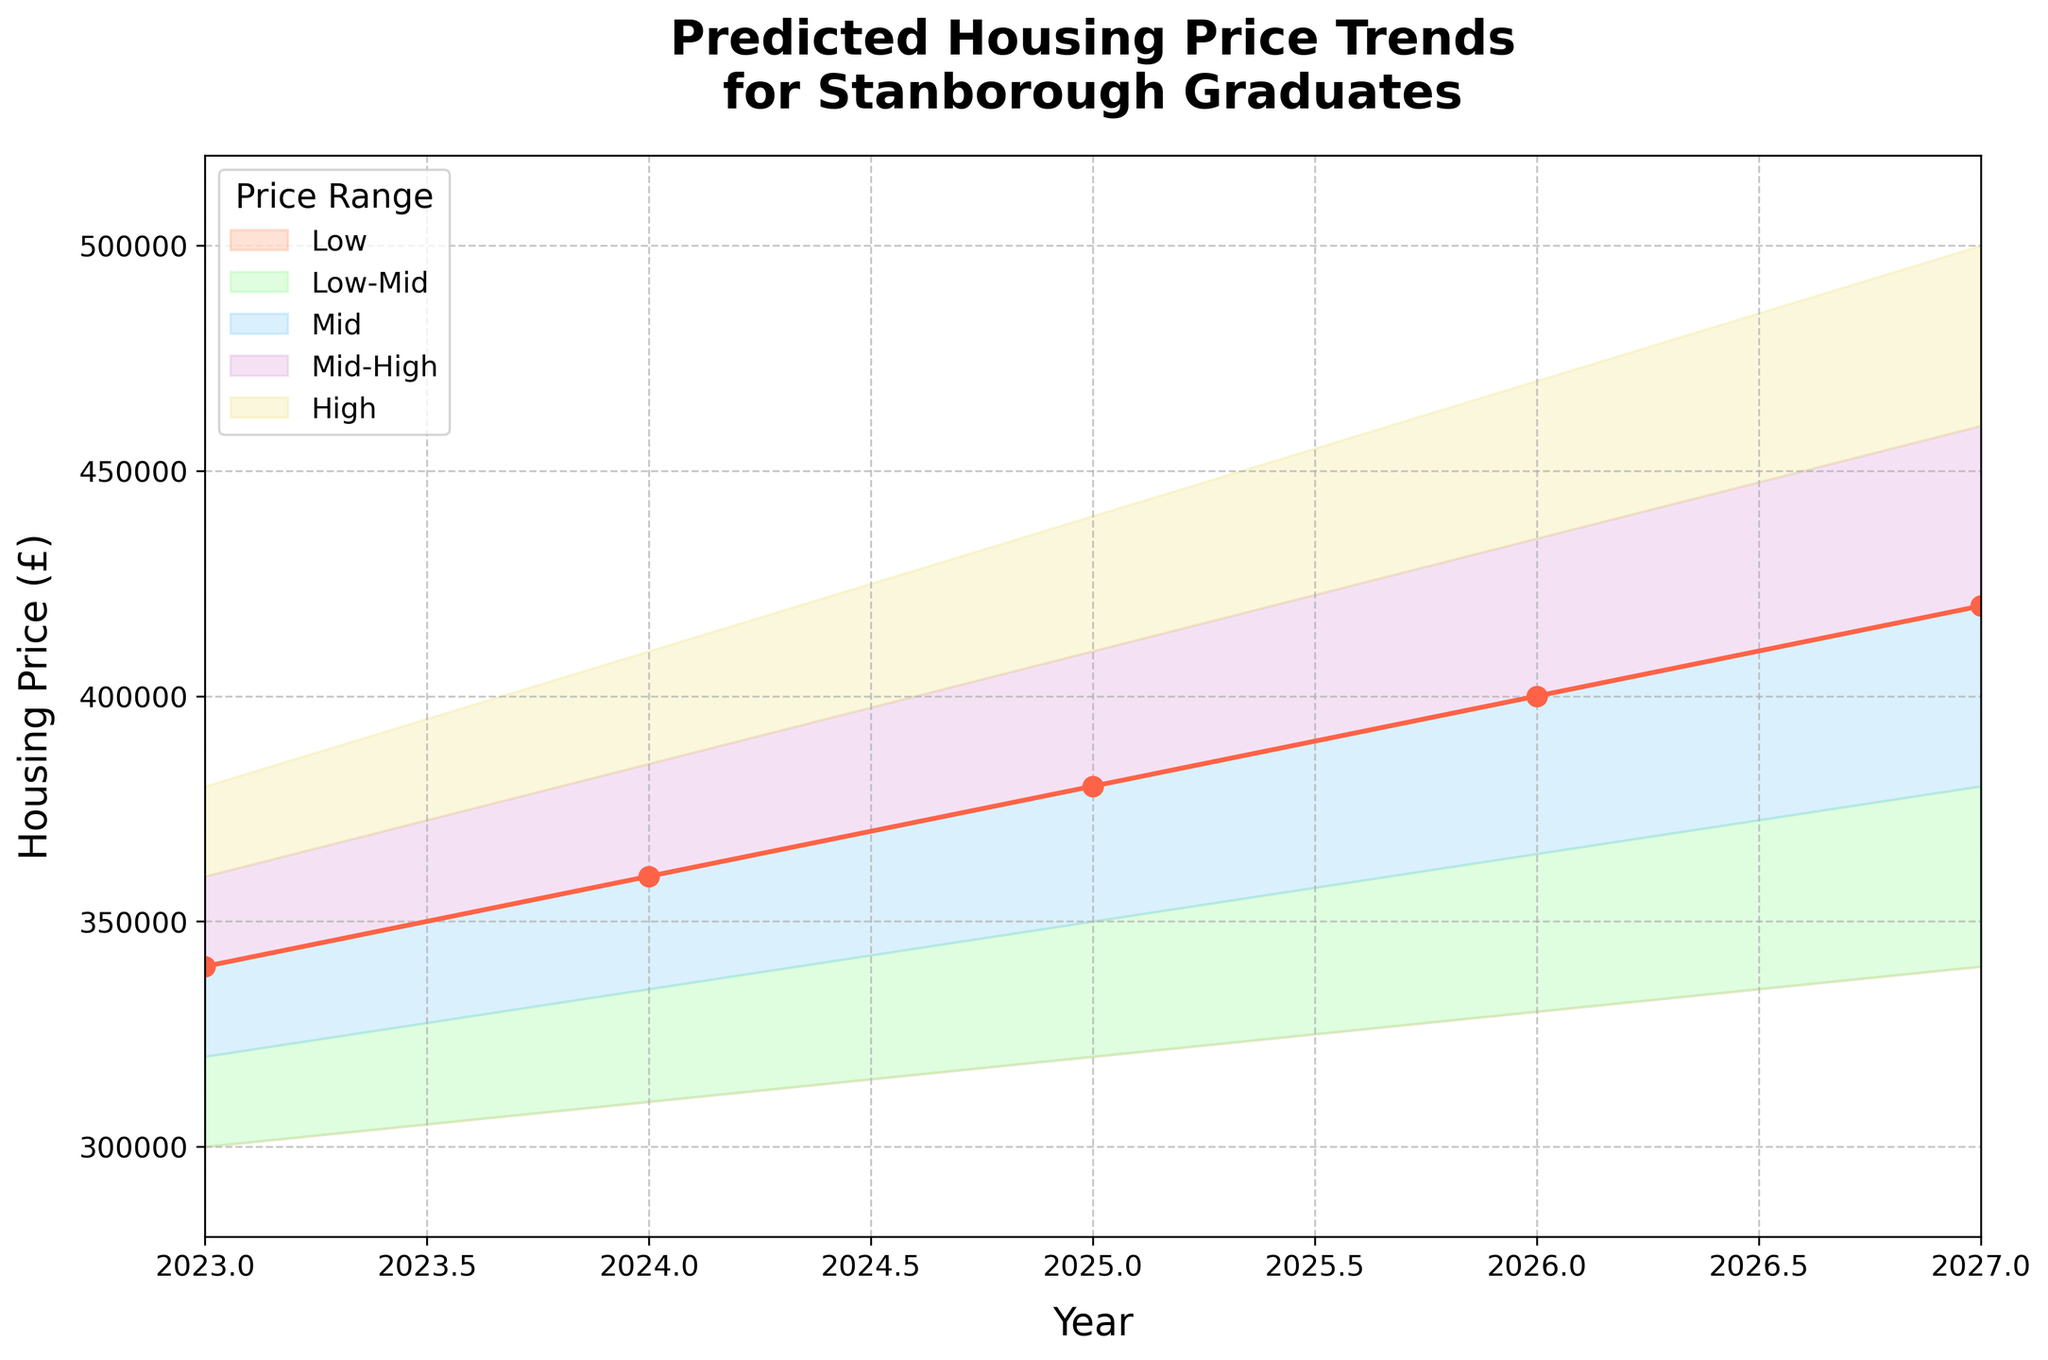What is the title of the figure? The figure title can be found at the top of the chart and reads "Predicted Housing Price Trends for Stanborough Graduates".
Answer: Predicted Housing Price Trends for Stanborough Graduates What is the predicted Mid housing price for 2025? To determine the predicted Mid housing price for 2025, refer to the 'Mid' line or band in the chart and look at the 2025 value on the x-axis. The value is 380000.
Answer: 380000 Which year shows the highest range between Low and High housing prices? Find the range for each year by subtracting the Low price from the High price. The highest range occurs in 2027, where it ranges from 340000 to 500000. The difference is 160000.
Answer: 2027 What color is used to represent the 'Mid-High' price range band? Look at the color legend, and see which color corresponds to 'Mid-High'. The color is represented in purple.
Answer: Purple What is the % increase in the predicted Low price from 2023 to 2027? First, find the Low prices for both years: 300000 (2023) and 340000 (2027). Then use the formula [(340000 - 300000) / 300000] * 100. The calculation yields approximately 13.33%.
Answer: 13.33% In which range band is there an overlap between the Low price of 2027 and the Mid price of 2023? Compare the Low price for 2027 (340000) with the prices from different bands in 2023. The overlapping band should be Mid, as the Mid price for 2023 is 340000.
Answer: Mid Which year shows the smallest predicted Mid-High housing price? Look at the Mid-High line or band for each year. The smallest Mid-High price is in 2023, where the value is 360000.
Answer: 2023 What is the trend of the predicted High housing prices from 2023 to 2027? Observe the line that represents the High price range from 2023 to 2027. It shows an upward trend increasing from 380000 to 500000 over the years.
Answer: Increasing How many total years of predictions are shown in the figure? Count the number of distinct years labeled on the x-axis. There are five years from 2023 to 2027.
Answer: Five What is the largest predicted difference between Low-Mid and Mid prices in any given year? Calculate the difference by subtracting Low-Mid prices from Mid prices for each year. The largest difference is in 2027, where the difference is 420000 - 380000 = 40000.
Answer: 40000 